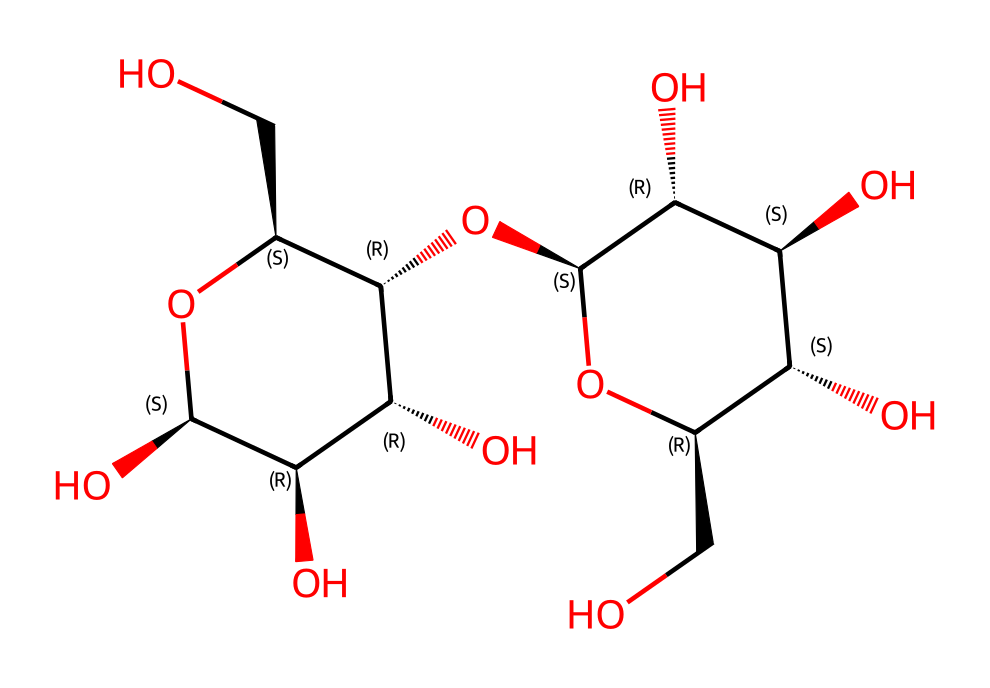How many carbon atoms are in cellobiose? To find the number of carbon atoms, examine the structural formula and count each carbon atom represented in the backbone and branch structures. There are 12 carbon atoms in cellobiose.
Answer: 12 What type of glycosidic bond is present in cellobiose? By looking at the connections between the monosaccharide units in the structure, the bond between the two glucose units shows that it is a beta-1,4-glycosidic bond, indicating a specific orientation of the hydroxyl groups during formation.
Answer: beta-1,4-glycosidic bond How many hydroxyl groups are in cellobiose? Inspect the structural formula for hydroxyl groups, which are identified by the –OH functional groups. Count all –OH groups present in the structure; there are 6 hydroxyl groups in total.
Answer: 6 What is the molecular formula of cellobiose? To derive the molecular formula, summarize the counts of each type of atom (C, H, O) present in the structure. The observed counts yield the molecular formula C12H22O11 for cellobiose.
Answer: C12H22O11 Which structural feature of cellobiose contributes to its solubility in water? The numerous hydroxyl (-OH) groups increase the polarity of the molecule, allowing it to form hydrogen bonds with water. This significant presence of hydroxyl groups is the key contributor to water solubility.
Answer: hydroxyl groups What is the significance of cellobiose in biofuel production? Cellobiose plays a crucial role in biofuel production as an intermediate product during cellulose breakdown, highlighting its importance as a substrate for enzymes in the degradation process.
Answer: substrate for enzymes 